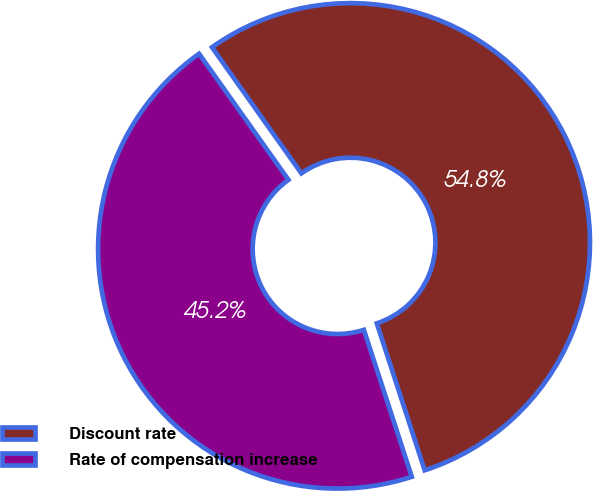Convert chart. <chart><loc_0><loc_0><loc_500><loc_500><pie_chart><fcel>Discount rate<fcel>Rate of compensation increase<nl><fcel>54.8%<fcel>45.2%<nl></chart> 